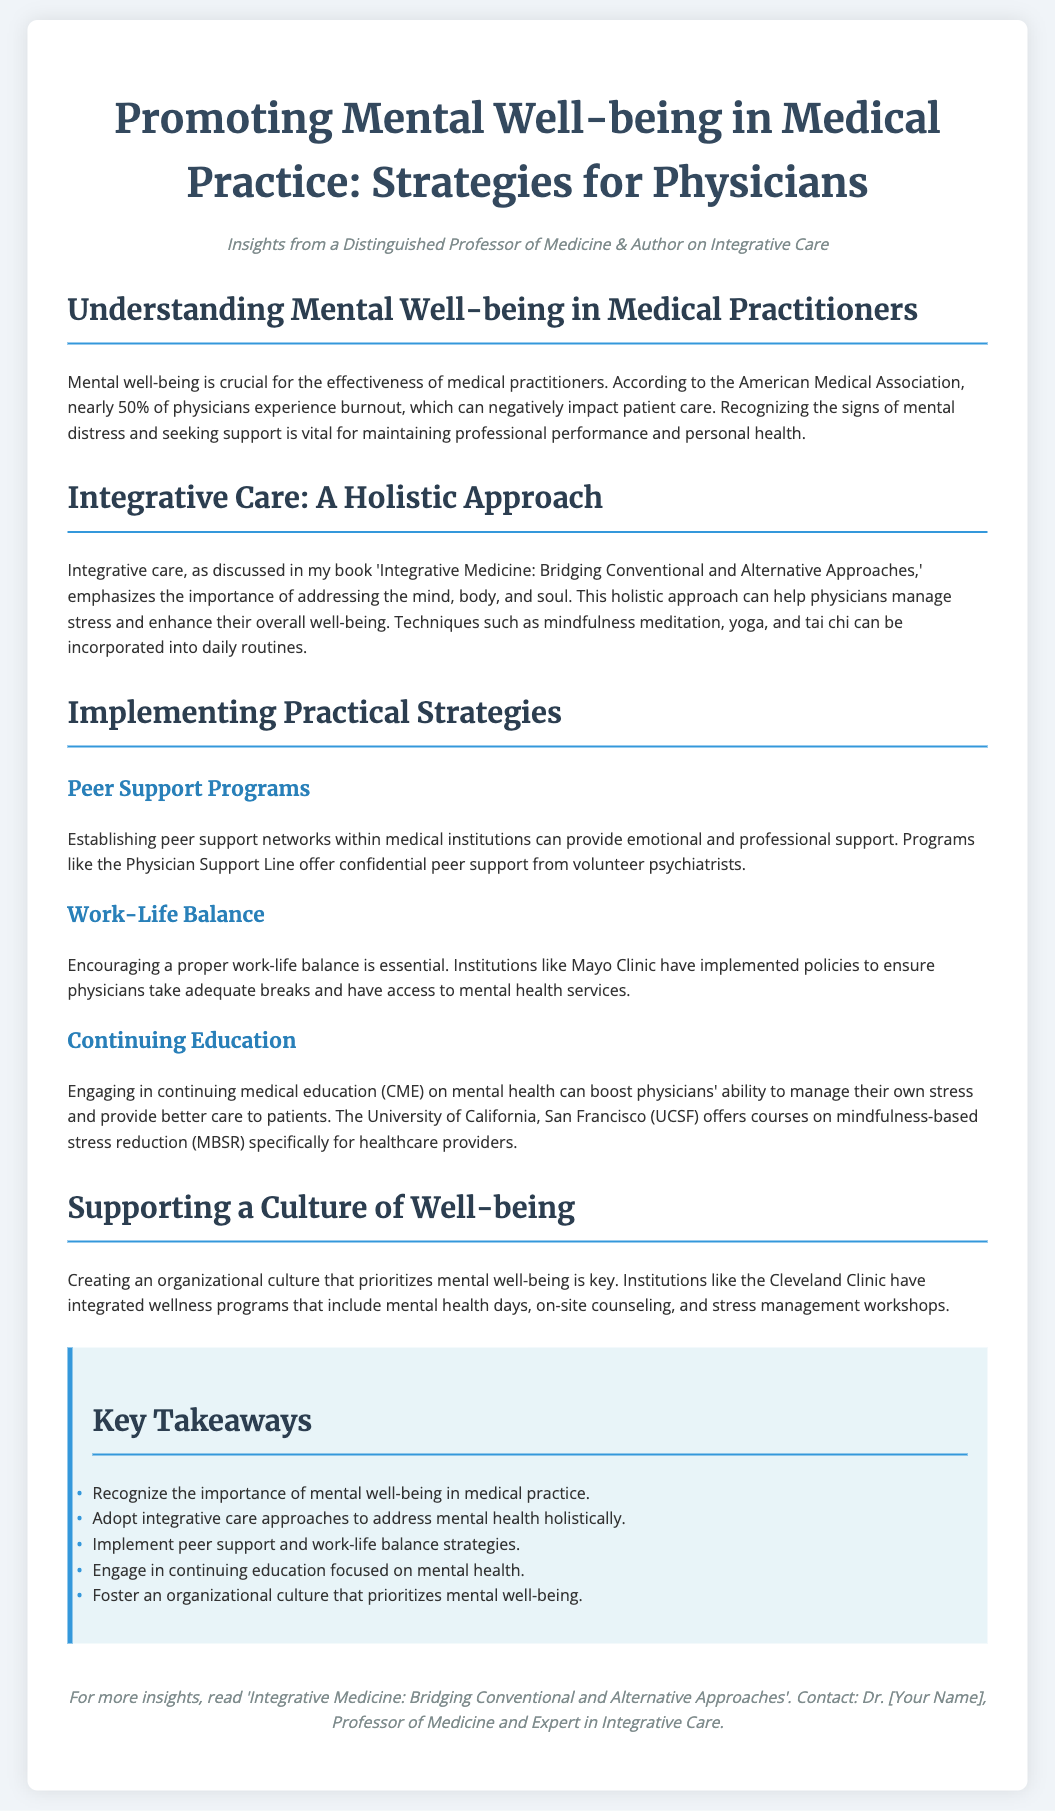what is the title of the flyer? The title is prominently displayed at the top of the document, indicating the focus on mental well-being in medical practices.
Answer: Promoting Mental Well-being in Medical Practice: Strategies for Physicians who authored the insights provided in this flyer? The author is mentioned in the subtitle, highlighting their expertise and background in integrative care.
Answer: A Distinguished Professor of Medicine & Author on Integrative Care how many physicians experience burnout according to the American Medical Association? The document references a statistic from the American Medical Association regarding physician burnout.
Answer: nearly 50% name one technique that can help physicians manage stress. The flyer lists techniques under the integrative care section for stress management.
Answer: mindfulness meditation what program offers confidential peer support from volunteer psychiatrists? The flyer mentions a specific program that provides support to physicians in need.
Answer: Physician Support Line what institution has implemented policies to ensure physicians take adequate breaks? A medical institution is cited for its practices regarding work-life balance.
Answer: Mayo Clinic which university offers courses on mindfulness-based stress reduction? The document highlights a specific educational institution providing relevant training for healthcare providers.
Answer: University of California, San Francisco (UCSF) what is emphasized as a key takeaway regarding organizational culture? The flyer lists important takeaways in a focused section on well-being culture in organizations.
Answer: prioritize mental well-being how many key takeaways are listed in the document? The key takeaways section summarizes several important points from the document.
Answer: five 